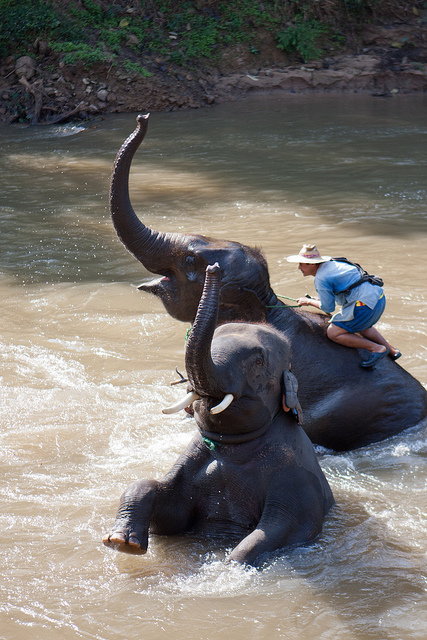<image>What age is the man riding the elephant? It is unanswerable what age is the man riding the elephant. What age is the man riding the elephant? It is unknown what age the man riding the elephant is. 